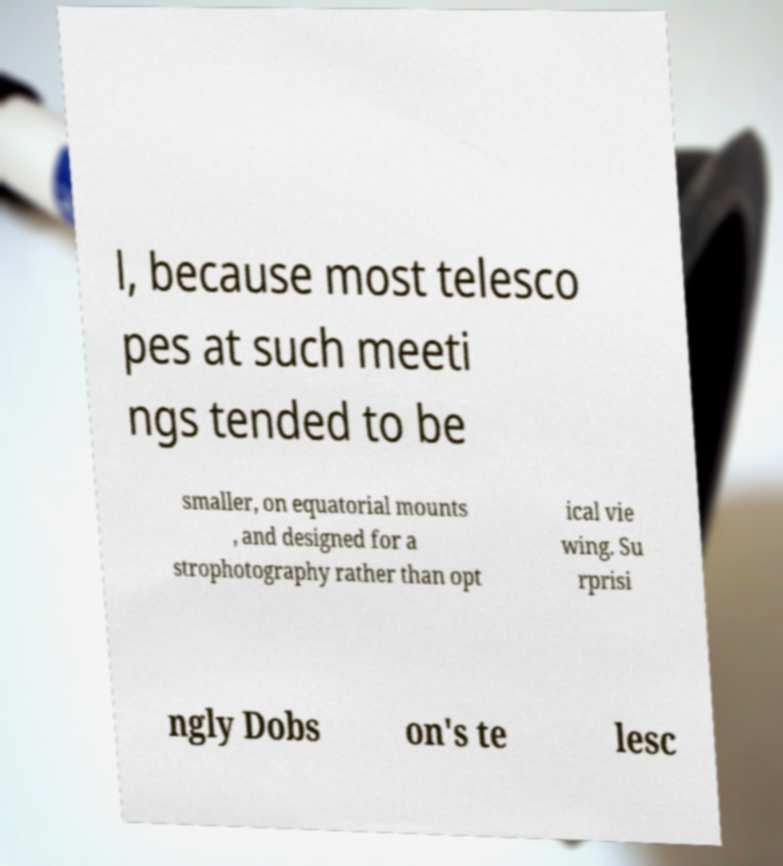I need the written content from this picture converted into text. Can you do that? l, because most telesco pes at such meeti ngs tended to be smaller, on equatorial mounts , and designed for a strophotography rather than opt ical vie wing. Su rprisi ngly Dobs on's te lesc 